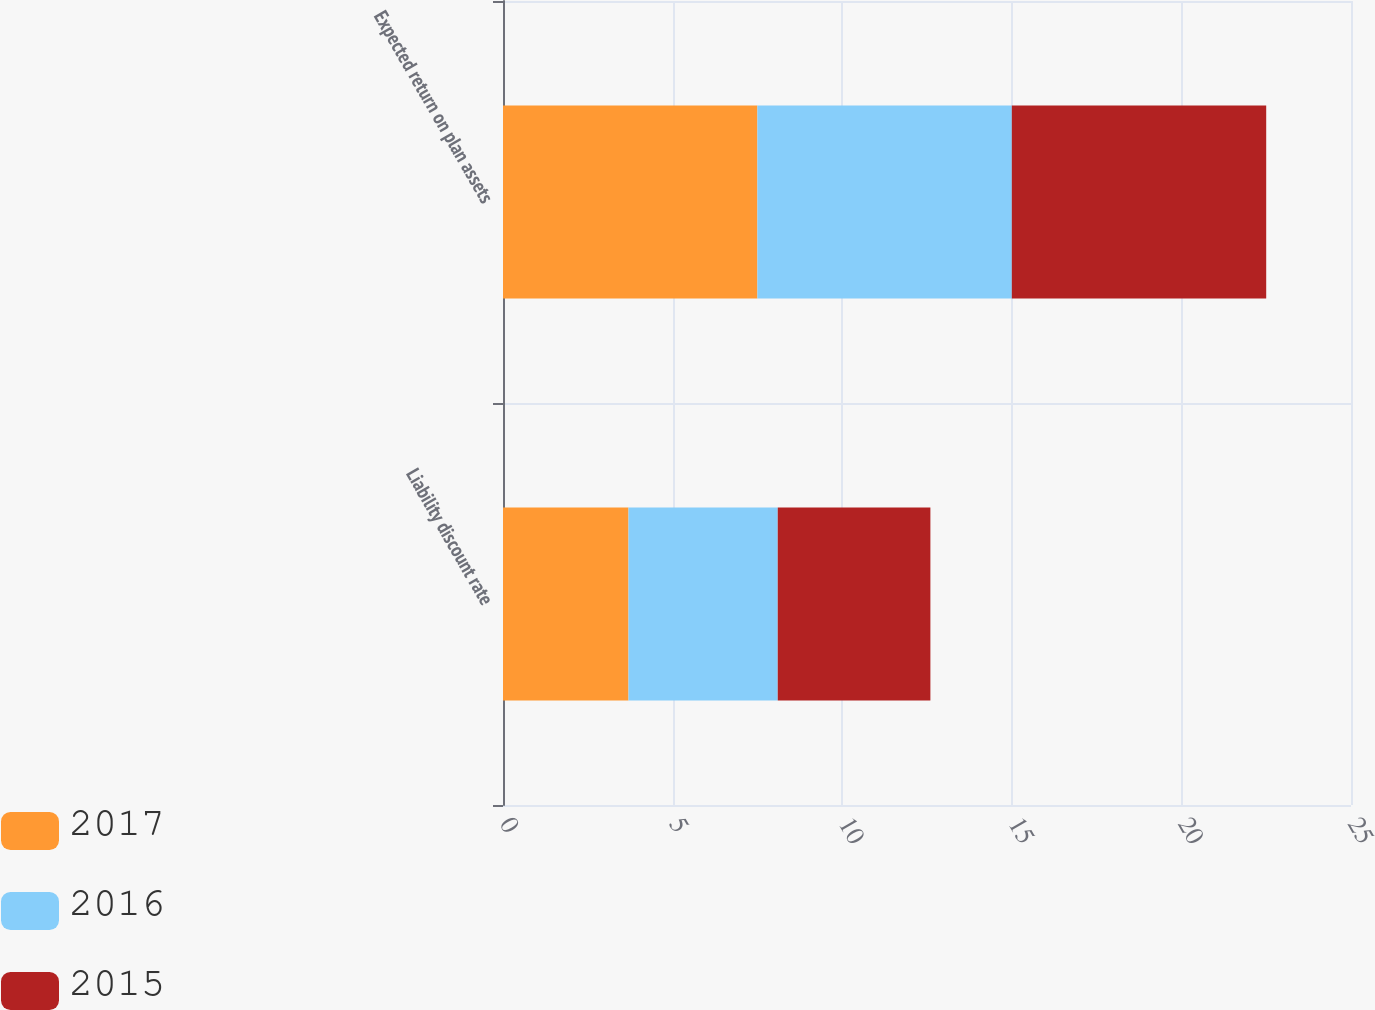<chart> <loc_0><loc_0><loc_500><loc_500><stacked_bar_chart><ecel><fcel>Liability discount rate<fcel>Expected return on plan assets<nl><fcel>2017<fcel>3.7<fcel>7.5<nl><fcel>2016<fcel>4.4<fcel>7.5<nl><fcel>2015<fcel>4.5<fcel>7.5<nl></chart> 